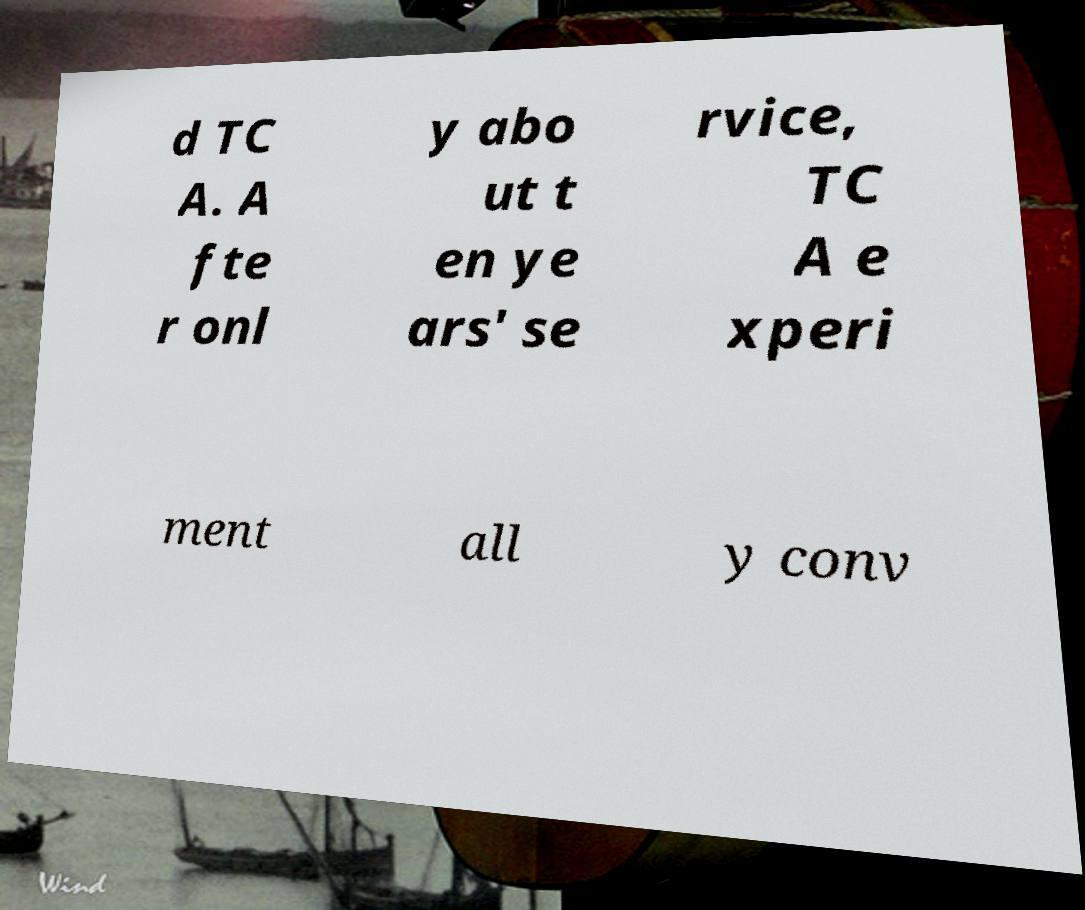What messages or text are displayed in this image? I need them in a readable, typed format. d TC A. A fte r onl y abo ut t en ye ars' se rvice, TC A e xperi ment all y conv 